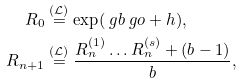Convert formula to latex. <formula><loc_0><loc_0><loc_500><loc_500>R _ { 0 } & \stackrel { ( \mathcal { L } ) } { = } \exp ( \ g b \ g o + h ) , \\ R _ { n + 1 } & \stackrel { ( \mathcal { L } ) } { = } \frac { R ^ { ( 1 ) } _ { n } \dots R ^ { ( s ) } _ { n } + ( b - 1 ) } { b } ,</formula> 